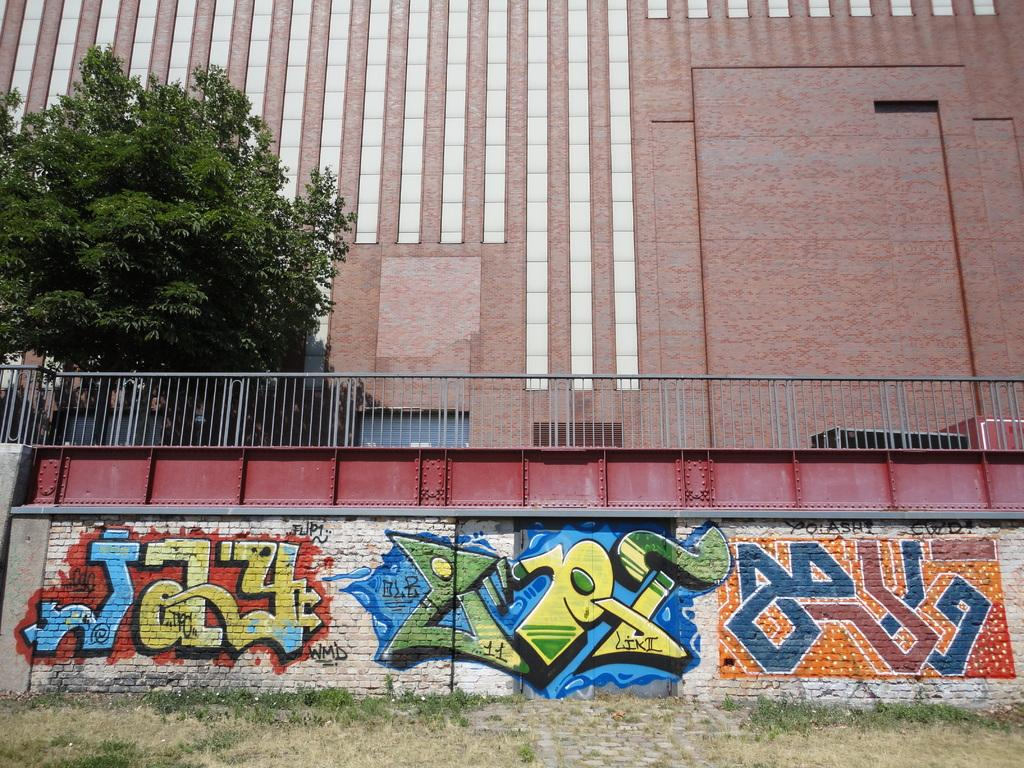What type of surface is on the ground in the image? There is grass on the ground in the image. What can be seen on the wall in the image? There is a painting on the wall in the image. What is visible in the background of the image? There is a building and a tree visible in the background of the image. How does the painting on the wall exchange ideas with the tree in the background? The painting on the wall and the tree in the background are not capable of exchanging ideas, as they are inanimate objects. What type of frame surrounds the painting in the image? There is no frame mentioned in the provided facts, so it cannot be determined from the image. 